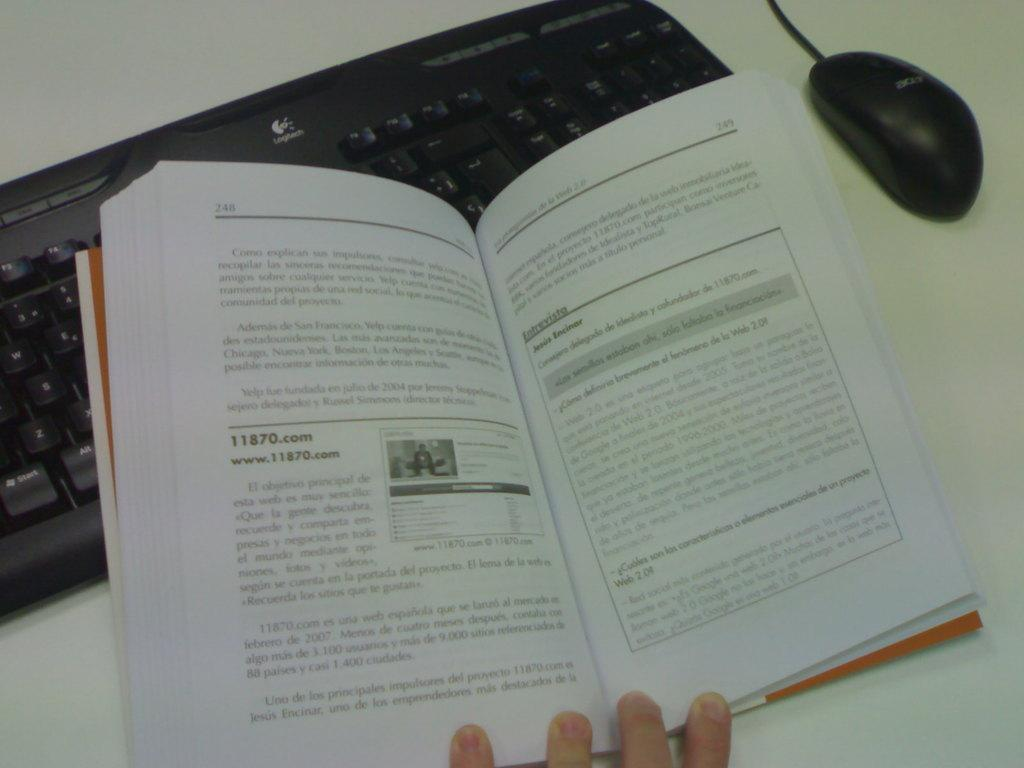<image>
Create a compact narrative representing the image presented. A book opened to page 248 and page 249, showing a website link for 11870.com 